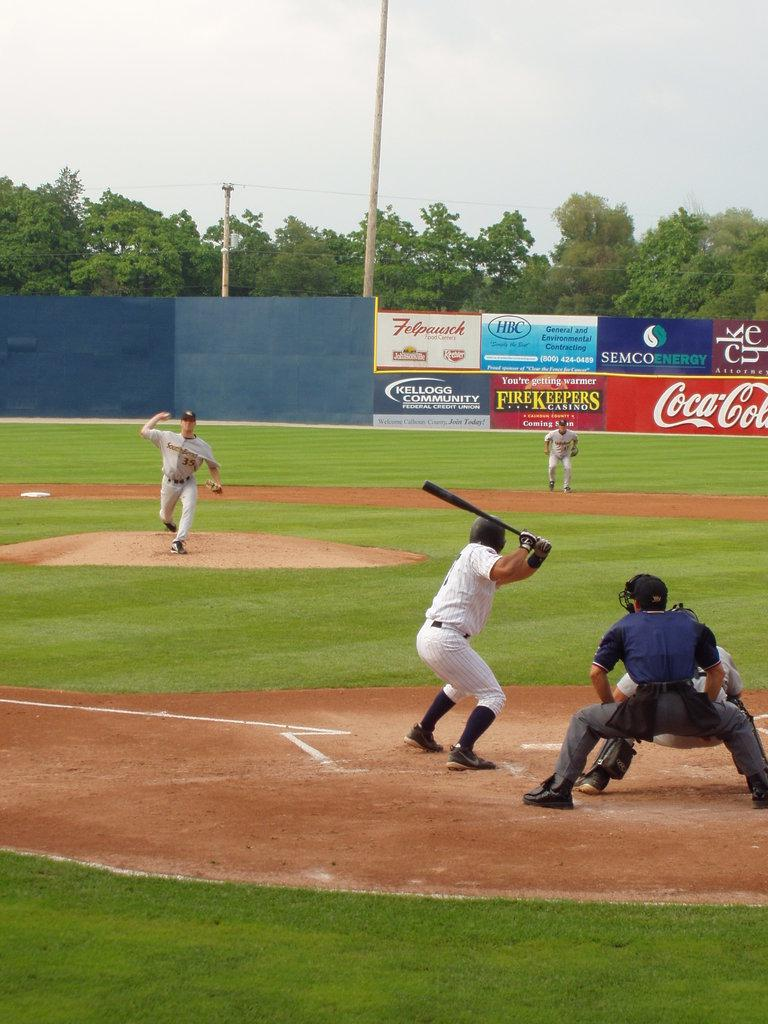<image>
Present a compact description of the photo's key features. A baseball player gets ready to bat in a stadium with a large Coca Cola ad. 